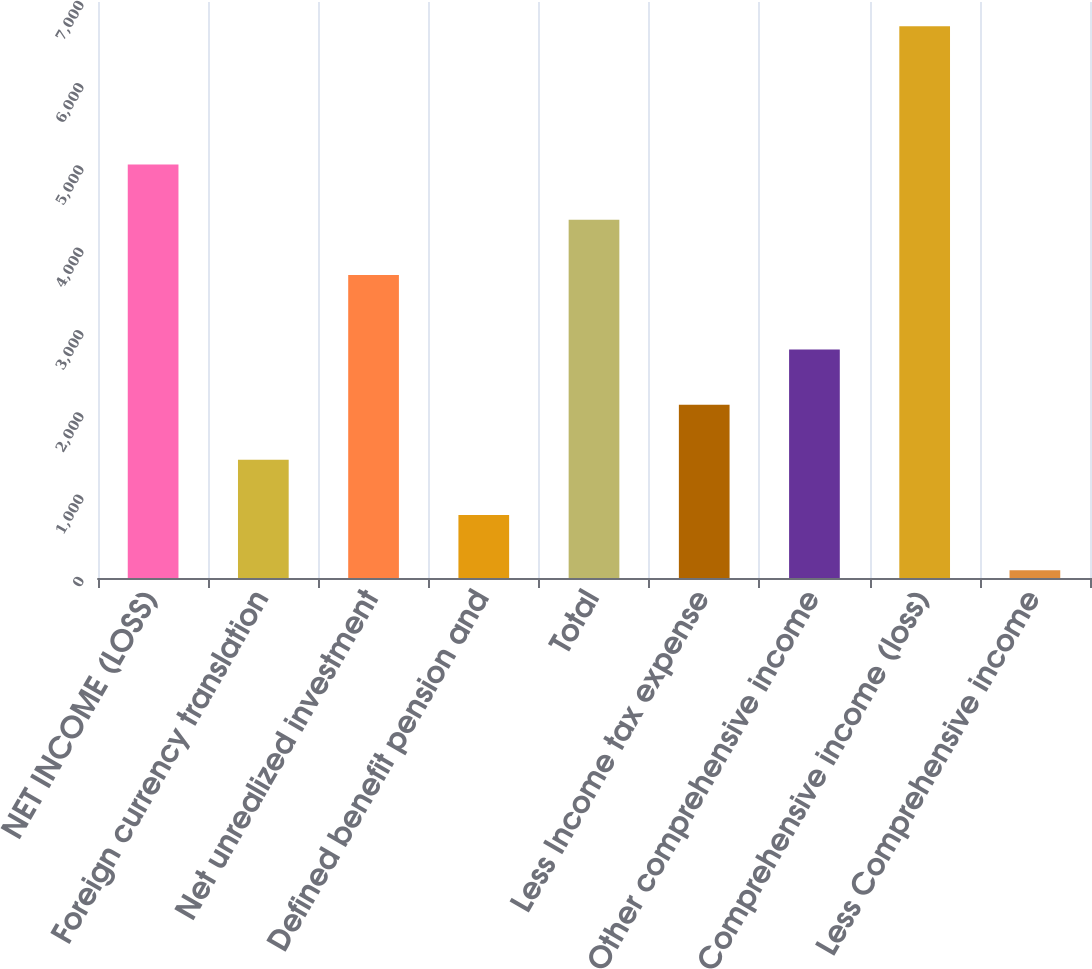<chart> <loc_0><loc_0><loc_500><loc_500><bar_chart><fcel>NET INCOME (LOSS)<fcel>Foreign currency translation<fcel>Net unrealized investment<fcel>Defined benefit pension and<fcel>Total<fcel>Less Income tax expense<fcel>Other comprehensive income<fcel>Comprehensive income (loss)<fcel>Less Comprehensive income<nl><fcel>5023.8<fcel>1435.8<fcel>3683<fcel>765.4<fcel>4353.4<fcel>2106.2<fcel>2776.6<fcel>6704<fcel>95<nl></chart> 